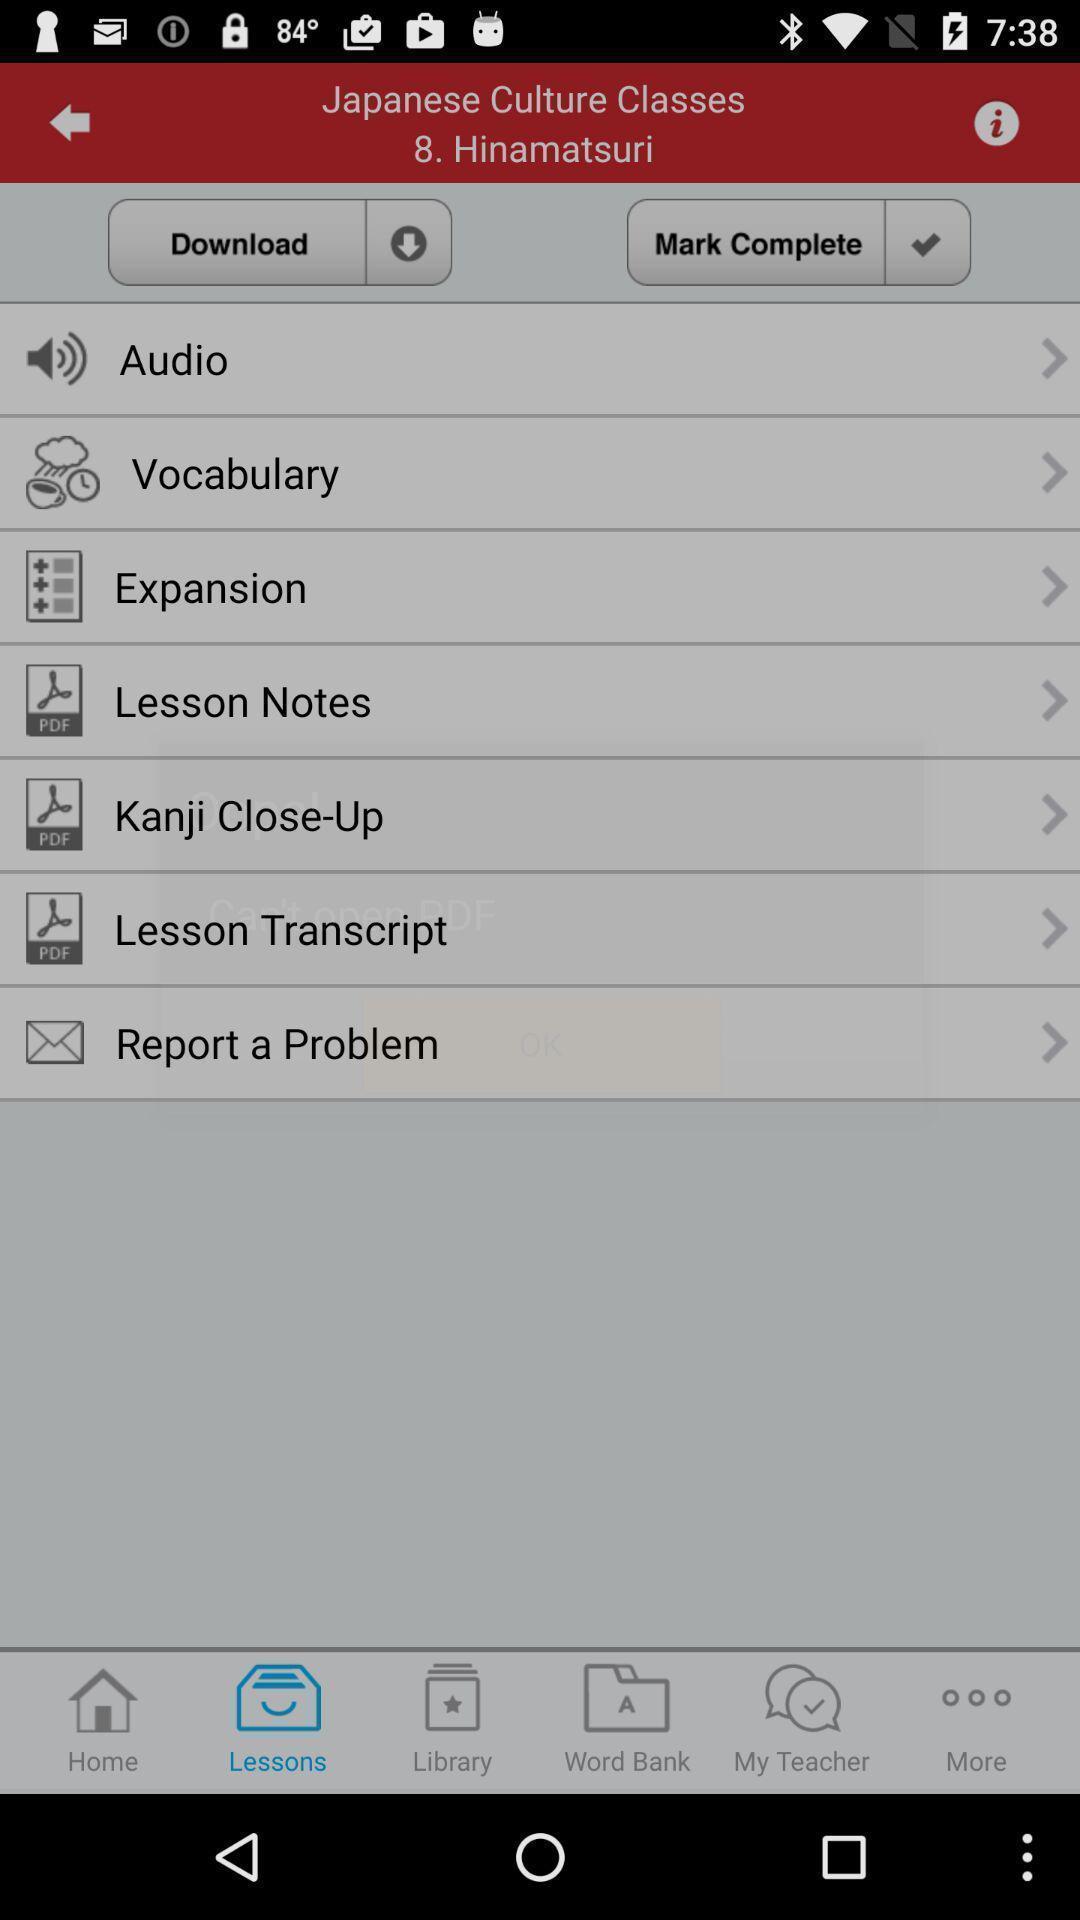Describe the content in this image. Screen displaying multiple features in a study app. 